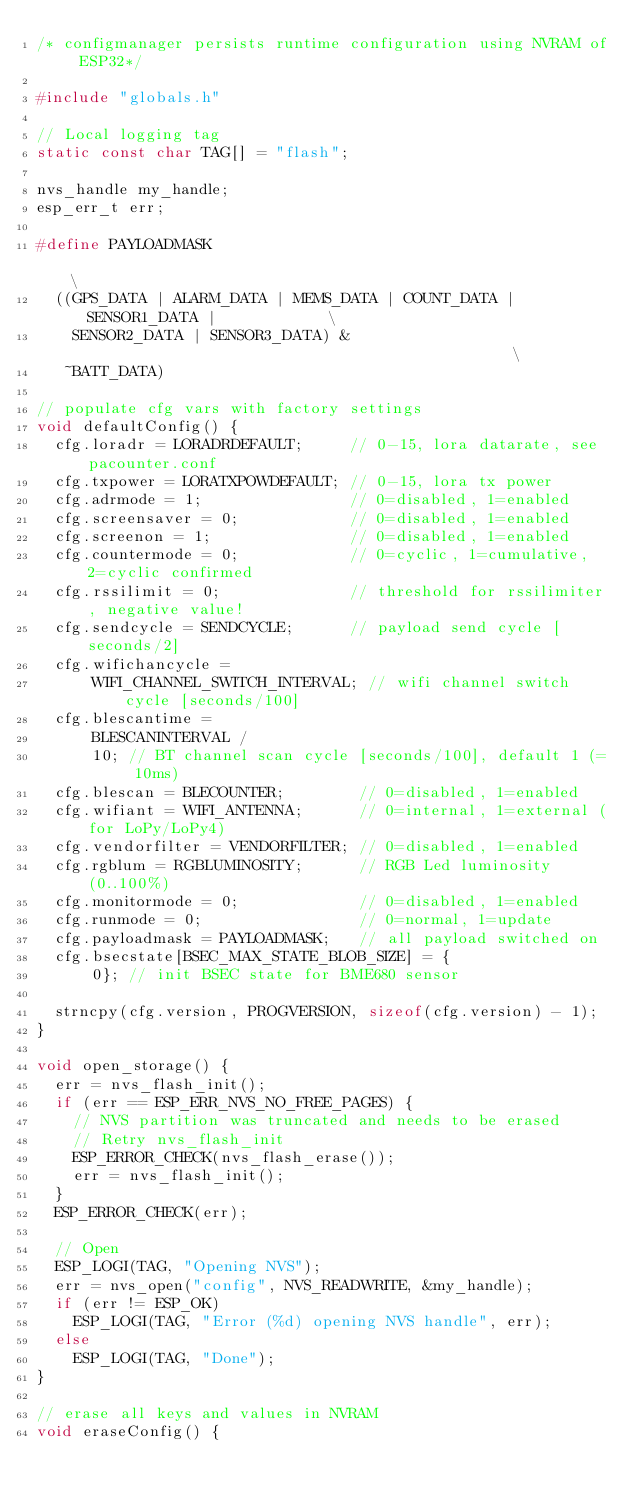Convert code to text. <code><loc_0><loc_0><loc_500><loc_500><_C++_>/* configmanager persists runtime configuration using NVRAM of ESP32*/

#include "globals.h"

// Local logging tag
static const char TAG[] = "flash";

nvs_handle my_handle;
esp_err_t err;

#define PAYLOADMASK                                                            \
  ((GPS_DATA | ALARM_DATA | MEMS_DATA | COUNT_DATA | SENSOR1_DATA |            \
    SENSOR2_DATA | SENSOR3_DATA) &                                             \
   ~BATT_DATA)

// populate cfg vars with factory settings
void defaultConfig() {
  cfg.loradr = LORADRDEFAULT;     // 0-15, lora datarate, see pacounter.conf
  cfg.txpower = LORATXPOWDEFAULT; // 0-15, lora tx power
  cfg.adrmode = 1;                // 0=disabled, 1=enabled
  cfg.screensaver = 0;            // 0=disabled, 1=enabled
  cfg.screenon = 1;               // 0=disabled, 1=enabled
  cfg.countermode = 0;            // 0=cyclic, 1=cumulative, 2=cyclic confirmed
  cfg.rssilimit = 0;              // threshold for rssilimiter, negative value!
  cfg.sendcycle = SENDCYCLE;      // payload send cycle [seconds/2]
  cfg.wifichancycle =
      WIFI_CHANNEL_SWITCH_INTERVAL; // wifi channel switch cycle [seconds/100]
  cfg.blescantime =
      BLESCANINTERVAL /
      10; // BT channel scan cycle [seconds/100], default 1 (= 10ms)
  cfg.blescan = BLECOUNTER;        // 0=disabled, 1=enabled
  cfg.wifiant = WIFI_ANTENNA;      // 0=internal, 1=external (for LoPy/LoPy4)
  cfg.vendorfilter = VENDORFILTER; // 0=disabled, 1=enabled
  cfg.rgblum = RGBLUMINOSITY;      // RGB Led luminosity (0..100%)
  cfg.monitormode = 0;             // 0=disabled, 1=enabled
  cfg.runmode = 0;                 // 0=normal, 1=update
  cfg.payloadmask = PAYLOADMASK;   // all payload switched on
  cfg.bsecstate[BSEC_MAX_STATE_BLOB_SIZE] = {
      0}; // init BSEC state for BME680 sensor

  strncpy(cfg.version, PROGVERSION, sizeof(cfg.version) - 1);
}

void open_storage() {
  err = nvs_flash_init();
  if (err == ESP_ERR_NVS_NO_FREE_PAGES) {
    // NVS partition was truncated and needs to be erased
    // Retry nvs_flash_init
    ESP_ERROR_CHECK(nvs_flash_erase());
    err = nvs_flash_init();
  }
  ESP_ERROR_CHECK(err);

  // Open
  ESP_LOGI(TAG, "Opening NVS");
  err = nvs_open("config", NVS_READWRITE, &my_handle);
  if (err != ESP_OK)
    ESP_LOGI(TAG, "Error (%d) opening NVS handle", err);
  else
    ESP_LOGI(TAG, "Done");
}

// erase all keys and values in NVRAM
void eraseConfig() {</code> 